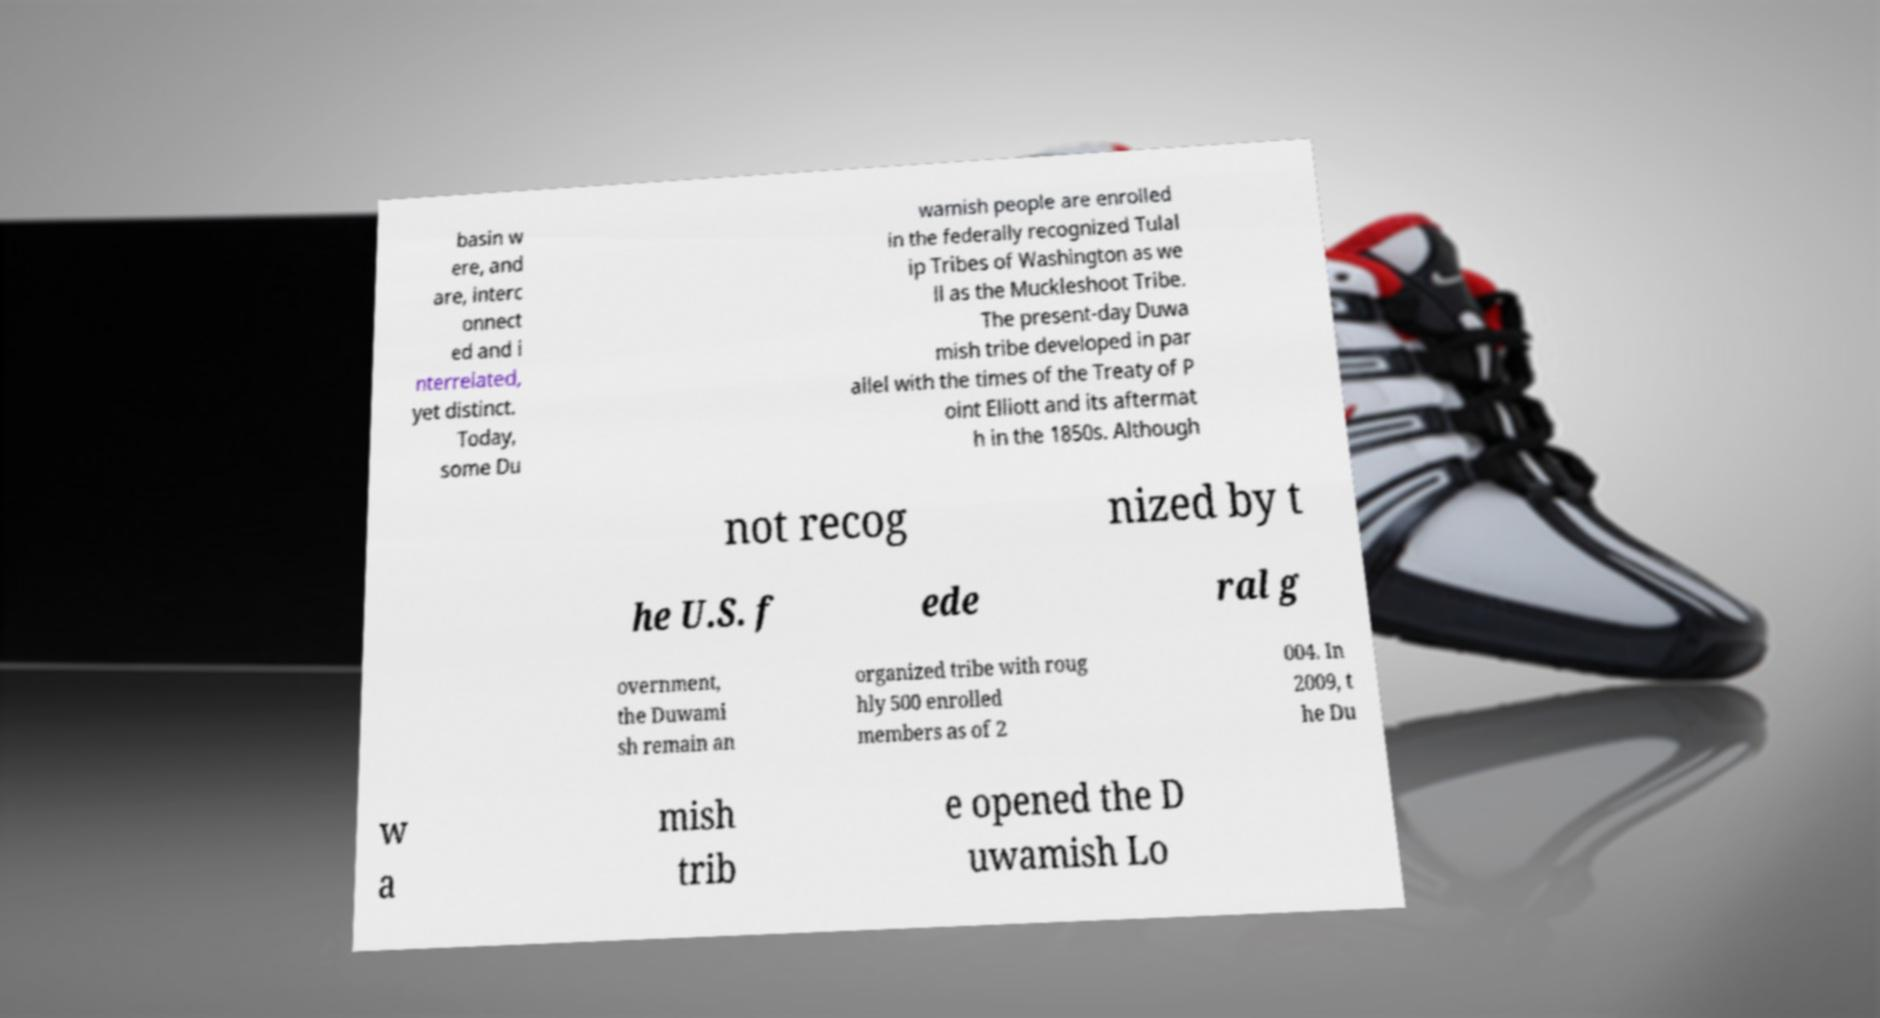Could you assist in decoding the text presented in this image and type it out clearly? basin w ere, and are, interc onnect ed and i nterrelated, yet distinct. Today, some Du wamish people are enrolled in the federally recognized Tulal ip Tribes of Washington as we ll as the Muckleshoot Tribe. The present-day Duwa mish tribe developed in par allel with the times of the Treaty of P oint Elliott and its aftermat h in the 1850s. Although not recog nized by t he U.S. f ede ral g overnment, the Duwami sh remain an organized tribe with roug hly 500 enrolled members as of 2 004. In 2009, t he Du w a mish trib e opened the D uwamish Lo 